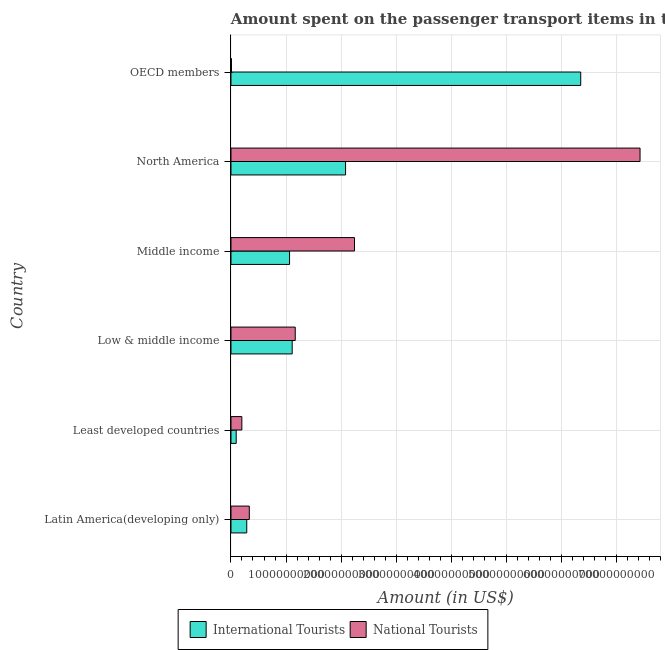How many different coloured bars are there?
Offer a very short reply. 2. How many groups of bars are there?
Your answer should be compact. 6. Are the number of bars per tick equal to the number of legend labels?
Your answer should be compact. Yes. How many bars are there on the 6th tick from the top?
Your answer should be compact. 2. What is the label of the 2nd group of bars from the top?
Keep it short and to the point. North America. In how many cases, is the number of bars for a given country not equal to the number of legend labels?
Your answer should be compact. 0. What is the amount spent on transport items of international tourists in Middle income?
Your answer should be very brief. 1.06e+1. Across all countries, what is the maximum amount spent on transport items of international tourists?
Your response must be concise. 6.35e+1. Across all countries, what is the minimum amount spent on transport items of international tourists?
Offer a terse response. 9.50e+08. In which country was the amount spent on transport items of national tourists maximum?
Your answer should be compact. North America. What is the total amount spent on transport items of international tourists in the graph?
Offer a terse response. 1.10e+11. What is the difference between the amount spent on transport items of national tourists in Least developed countries and that in Low & middle income?
Your answer should be very brief. -9.70e+09. What is the difference between the amount spent on transport items of international tourists in OECD members and the amount spent on transport items of national tourists in North America?
Offer a terse response. -1.08e+1. What is the average amount spent on transport items of international tourists per country?
Make the answer very short. 1.83e+1. What is the difference between the amount spent on transport items of national tourists and amount spent on transport items of international tourists in North America?
Ensure brevity in your answer.  5.35e+1. What is the ratio of the amount spent on transport items of international tourists in North America to that in OECD members?
Ensure brevity in your answer.  0.33. Is the amount spent on transport items of international tourists in Low & middle income less than that in OECD members?
Ensure brevity in your answer.  Yes. Is the difference between the amount spent on transport items of international tourists in Latin America(developing only) and North America greater than the difference between the amount spent on transport items of national tourists in Latin America(developing only) and North America?
Provide a short and direct response. Yes. What is the difference between the highest and the second highest amount spent on transport items of national tourists?
Offer a terse response. 5.19e+1. What is the difference between the highest and the lowest amount spent on transport items of national tourists?
Your answer should be compact. 7.42e+1. In how many countries, is the amount spent on transport items of national tourists greater than the average amount spent on transport items of national tourists taken over all countries?
Give a very brief answer. 2. What does the 2nd bar from the top in North America represents?
Give a very brief answer. International Tourists. What does the 2nd bar from the bottom in Middle income represents?
Keep it short and to the point. National Tourists. How many bars are there?
Provide a succinct answer. 12. How many countries are there in the graph?
Ensure brevity in your answer.  6. What is the difference between two consecutive major ticks on the X-axis?
Provide a short and direct response. 1.00e+1. Are the values on the major ticks of X-axis written in scientific E-notation?
Your answer should be compact. No. Does the graph contain any zero values?
Keep it short and to the point. No. How many legend labels are there?
Offer a very short reply. 2. How are the legend labels stacked?
Offer a terse response. Horizontal. What is the title of the graph?
Your response must be concise. Amount spent on the passenger transport items in the year 1997. Does "From World Bank" appear as one of the legend labels in the graph?
Make the answer very short. No. What is the label or title of the X-axis?
Give a very brief answer. Amount (in US$). What is the Amount (in US$) of International Tourists in Latin America(developing only)?
Your answer should be compact. 2.87e+09. What is the Amount (in US$) of National Tourists in Latin America(developing only)?
Give a very brief answer. 3.33e+09. What is the Amount (in US$) of International Tourists in Least developed countries?
Ensure brevity in your answer.  9.50e+08. What is the Amount (in US$) of National Tourists in Least developed countries?
Your answer should be compact. 1.97e+09. What is the Amount (in US$) in International Tourists in Low & middle income?
Make the answer very short. 1.11e+1. What is the Amount (in US$) of National Tourists in Low & middle income?
Make the answer very short. 1.17e+1. What is the Amount (in US$) in International Tourists in Middle income?
Offer a very short reply. 1.06e+1. What is the Amount (in US$) in National Tourists in Middle income?
Your answer should be compact. 2.24e+1. What is the Amount (in US$) of International Tourists in North America?
Give a very brief answer. 2.08e+1. What is the Amount (in US$) in National Tourists in North America?
Your answer should be compact. 7.43e+1. What is the Amount (in US$) of International Tourists in OECD members?
Offer a terse response. 6.35e+1. What is the Amount (in US$) in National Tourists in OECD members?
Provide a succinct answer. 8.96e+07. Across all countries, what is the maximum Amount (in US$) in International Tourists?
Give a very brief answer. 6.35e+1. Across all countries, what is the maximum Amount (in US$) in National Tourists?
Provide a short and direct response. 7.43e+1. Across all countries, what is the minimum Amount (in US$) in International Tourists?
Make the answer very short. 9.50e+08. Across all countries, what is the minimum Amount (in US$) in National Tourists?
Your answer should be very brief. 8.96e+07. What is the total Amount (in US$) in International Tourists in the graph?
Your answer should be very brief. 1.10e+11. What is the total Amount (in US$) of National Tourists in the graph?
Provide a succinct answer. 1.14e+11. What is the difference between the Amount (in US$) of International Tourists in Latin America(developing only) and that in Least developed countries?
Offer a terse response. 1.92e+09. What is the difference between the Amount (in US$) of National Tourists in Latin America(developing only) and that in Least developed countries?
Offer a very short reply. 1.35e+09. What is the difference between the Amount (in US$) in International Tourists in Latin America(developing only) and that in Low & middle income?
Your answer should be compact. -8.25e+09. What is the difference between the Amount (in US$) of National Tourists in Latin America(developing only) and that in Low & middle income?
Your response must be concise. -8.35e+09. What is the difference between the Amount (in US$) in International Tourists in Latin America(developing only) and that in Middle income?
Provide a succinct answer. -7.78e+09. What is the difference between the Amount (in US$) of National Tourists in Latin America(developing only) and that in Middle income?
Your answer should be very brief. -1.91e+1. What is the difference between the Amount (in US$) in International Tourists in Latin America(developing only) and that in North America?
Keep it short and to the point. -1.80e+1. What is the difference between the Amount (in US$) of National Tourists in Latin America(developing only) and that in North America?
Your response must be concise. -7.10e+1. What is the difference between the Amount (in US$) of International Tourists in Latin America(developing only) and that in OECD members?
Provide a short and direct response. -6.07e+1. What is the difference between the Amount (in US$) in National Tourists in Latin America(developing only) and that in OECD members?
Give a very brief answer. 3.24e+09. What is the difference between the Amount (in US$) of International Tourists in Least developed countries and that in Low & middle income?
Make the answer very short. -1.02e+1. What is the difference between the Amount (in US$) in National Tourists in Least developed countries and that in Low & middle income?
Ensure brevity in your answer.  -9.70e+09. What is the difference between the Amount (in US$) in International Tourists in Least developed countries and that in Middle income?
Your answer should be very brief. -9.70e+09. What is the difference between the Amount (in US$) of National Tourists in Least developed countries and that in Middle income?
Provide a short and direct response. -2.05e+1. What is the difference between the Amount (in US$) in International Tourists in Least developed countries and that in North America?
Your answer should be very brief. -1.99e+1. What is the difference between the Amount (in US$) in National Tourists in Least developed countries and that in North America?
Offer a terse response. -7.24e+1. What is the difference between the Amount (in US$) in International Tourists in Least developed countries and that in OECD members?
Give a very brief answer. -6.26e+1. What is the difference between the Amount (in US$) in National Tourists in Least developed countries and that in OECD members?
Keep it short and to the point. 1.88e+09. What is the difference between the Amount (in US$) in International Tourists in Low & middle income and that in Middle income?
Provide a short and direct response. 4.76e+08. What is the difference between the Amount (in US$) of National Tourists in Low & middle income and that in Middle income?
Give a very brief answer. -1.08e+1. What is the difference between the Amount (in US$) in International Tourists in Low & middle income and that in North America?
Your answer should be very brief. -9.70e+09. What is the difference between the Amount (in US$) in National Tourists in Low & middle income and that in North America?
Provide a short and direct response. -6.27e+1. What is the difference between the Amount (in US$) of International Tourists in Low & middle income and that in OECD members?
Your answer should be very brief. -5.24e+1. What is the difference between the Amount (in US$) in National Tourists in Low & middle income and that in OECD members?
Give a very brief answer. 1.16e+1. What is the difference between the Amount (in US$) of International Tourists in Middle income and that in North America?
Offer a very short reply. -1.02e+1. What is the difference between the Amount (in US$) in National Tourists in Middle income and that in North America?
Provide a succinct answer. -5.19e+1. What is the difference between the Amount (in US$) of International Tourists in Middle income and that in OECD members?
Your answer should be very brief. -5.29e+1. What is the difference between the Amount (in US$) of National Tourists in Middle income and that in OECD members?
Offer a terse response. 2.24e+1. What is the difference between the Amount (in US$) of International Tourists in North America and that in OECD members?
Give a very brief answer. -4.27e+1. What is the difference between the Amount (in US$) in National Tourists in North America and that in OECD members?
Your answer should be compact. 7.42e+1. What is the difference between the Amount (in US$) in International Tourists in Latin America(developing only) and the Amount (in US$) in National Tourists in Least developed countries?
Provide a short and direct response. 8.92e+08. What is the difference between the Amount (in US$) in International Tourists in Latin America(developing only) and the Amount (in US$) in National Tourists in Low & middle income?
Keep it short and to the point. -8.81e+09. What is the difference between the Amount (in US$) of International Tourists in Latin America(developing only) and the Amount (in US$) of National Tourists in Middle income?
Give a very brief answer. -1.96e+1. What is the difference between the Amount (in US$) in International Tourists in Latin America(developing only) and the Amount (in US$) in National Tourists in North America?
Ensure brevity in your answer.  -7.15e+1. What is the difference between the Amount (in US$) of International Tourists in Latin America(developing only) and the Amount (in US$) of National Tourists in OECD members?
Your response must be concise. 2.78e+09. What is the difference between the Amount (in US$) of International Tourists in Least developed countries and the Amount (in US$) of National Tourists in Low & middle income?
Keep it short and to the point. -1.07e+1. What is the difference between the Amount (in US$) in International Tourists in Least developed countries and the Amount (in US$) in National Tourists in Middle income?
Keep it short and to the point. -2.15e+1. What is the difference between the Amount (in US$) of International Tourists in Least developed countries and the Amount (in US$) of National Tourists in North America?
Provide a succinct answer. -7.34e+1. What is the difference between the Amount (in US$) of International Tourists in Least developed countries and the Amount (in US$) of National Tourists in OECD members?
Ensure brevity in your answer.  8.60e+08. What is the difference between the Amount (in US$) of International Tourists in Low & middle income and the Amount (in US$) of National Tourists in Middle income?
Offer a very short reply. -1.13e+1. What is the difference between the Amount (in US$) in International Tourists in Low & middle income and the Amount (in US$) in National Tourists in North America?
Offer a very short reply. -6.32e+1. What is the difference between the Amount (in US$) of International Tourists in Low & middle income and the Amount (in US$) of National Tourists in OECD members?
Keep it short and to the point. 1.10e+1. What is the difference between the Amount (in US$) of International Tourists in Middle income and the Amount (in US$) of National Tourists in North America?
Keep it short and to the point. -6.37e+1. What is the difference between the Amount (in US$) of International Tourists in Middle income and the Amount (in US$) of National Tourists in OECD members?
Offer a very short reply. 1.06e+1. What is the difference between the Amount (in US$) in International Tourists in North America and the Amount (in US$) in National Tourists in OECD members?
Provide a short and direct response. 2.07e+1. What is the average Amount (in US$) in International Tourists per country?
Your answer should be compact. 1.83e+1. What is the average Amount (in US$) of National Tourists per country?
Your answer should be very brief. 1.90e+1. What is the difference between the Amount (in US$) in International Tourists and Amount (in US$) in National Tourists in Latin America(developing only)?
Your answer should be compact. -4.62e+08. What is the difference between the Amount (in US$) in International Tourists and Amount (in US$) in National Tourists in Least developed countries?
Keep it short and to the point. -1.02e+09. What is the difference between the Amount (in US$) in International Tourists and Amount (in US$) in National Tourists in Low & middle income?
Provide a succinct answer. -5.54e+08. What is the difference between the Amount (in US$) of International Tourists and Amount (in US$) of National Tourists in Middle income?
Provide a succinct answer. -1.18e+1. What is the difference between the Amount (in US$) of International Tourists and Amount (in US$) of National Tourists in North America?
Your answer should be compact. -5.35e+1. What is the difference between the Amount (in US$) in International Tourists and Amount (in US$) in National Tourists in OECD members?
Make the answer very short. 6.35e+1. What is the ratio of the Amount (in US$) in International Tourists in Latin America(developing only) to that in Least developed countries?
Provide a short and direct response. 3.02. What is the ratio of the Amount (in US$) of National Tourists in Latin America(developing only) to that in Least developed countries?
Your response must be concise. 1.69. What is the ratio of the Amount (in US$) in International Tourists in Latin America(developing only) to that in Low & middle income?
Provide a succinct answer. 0.26. What is the ratio of the Amount (in US$) of National Tourists in Latin America(developing only) to that in Low & middle income?
Provide a short and direct response. 0.29. What is the ratio of the Amount (in US$) of International Tourists in Latin America(developing only) to that in Middle income?
Provide a short and direct response. 0.27. What is the ratio of the Amount (in US$) in National Tourists in Latin America(developing only) to that in Middle income?
Keep it short and to the point. 0.15. What is the ratio of the Amount (in US$) of International Tourists in Latin America(developing only) to that in North America?
Your answer should be very brief. 0.14. What is the ratio of the Amount (in US$) of National Tourists in Latin America(developing only) to that in North America?
Offer a terse response. 0.04. What is the ratio of the Amount (in US$) of International Tourists in Latin America(developing only) to that in OECD members?
Ensure brevity in your answer.  0.05. What is the ratio of the Amount (in US$) of National Tourists in Latin America(developing only) to that in OECD members?
Give a very brief answer. 37.13. What is the ratio of the Amount (in US$) in International Tourists in Least developed countries to that in Low & middle income?
Provide a short and direct response. 0.09. What is the ratio of the Amount (in US$) in National Tourists in Least developed countries to that in Low & middle income?
Give a very brief answer. 0.17. What is the ratio of the Amount (in US$) of International Tourists in Least developed countries to that in Middle income?
Offer a terse response. 0.09. What is the ratio of the Amount (in US$) of National Tourists in Least developed countries to that in Middle income?
Your response must be concise. 0.09. What is the ratio of the Amount (in US$) of International Tourists in Least developed countries to that in North America?
Make the answer very short. 0.05. What is the ratio of the Amount (in US$) in National Tourists in Least developed countries to that in North America?
Give a very brief answer. 0.03. What is the ratio of the Amount (in US$) in International Tourists in Least developed countries to that in OECD members?
Keep it short and to the point. 0.01. What is the ratio of the Amount (in US$) in National Tourists in Least developed countries to that in OECD members?
Give a very brief answer. 22.03. What is the ratio of the Amount (in US$) of International Tourists in Low & middle income to that in Middle income?
Your answer should be compact. 1.04. What is the ratio of the Amount (in US$) in National Tourists in Low & middle income to that in Middle income?
Offer a terse response. 0.52. What is the ratio of the Amount (in US$) in International Tourists in Low & middle income to that in North America?
Provide a short and direct response. 0.53. What is the ratio of the Amount (in US$) of National Tourists in Low & middle income to that in North America?
Your answer should be very brief. 0.16. What is the ratio of the Amount (in US$) in International Tourists in Low & middle income to that in OECD members?
Your answer should be very brief. 0.17. What is the ratio of the Amount (in US$) in National Tourists in Low & middle income to that in OECD members?
Offer a terse response. 130.26. What is the ratio of the Amount (in US$) of International Tourists in Middle income to that in North America?
Your answer should be very brief. 0.51. What is the ratio of the Amount (in US$) in National Tourists in Middle income to that in North America?
Make the answer very short. 0.3. What is the ratio of the Amount (in US$) in International Tourists in Middle income to that in OECD members?
Your answer should be compact. 0.17. What is the ratio of the Amount (in US$) of National Tourists in Middle income to that in OECD members?
Your answer should be compact. 250.41. What is the ratio of the Amount (in US$) in International Tourists in North America to that in OECD members?
Offer a terse response. 0.33. What is the ratio of the Amount (in US$) in National Tourists in North America to that in OECD members?
Ensure brevity in your answer.  829.26. What is the difference between the highest and the second highest Amount (in US$) in International Tourists?
Your answer should be compact. 4.27e+1. What is the difference between the highest and the second highest Amount (in US$) of National Tourists?
Give a very brief answer. 5.19e+1. What is the difference between the highest and the lowest Amount (in US$) of International Tourists?
Your response must be concise. 6.26e+1. What is the difference between the highest and the lowest Amount (in US$) in National Tourists?
Provide a succinct answer. 7.42e+1. 